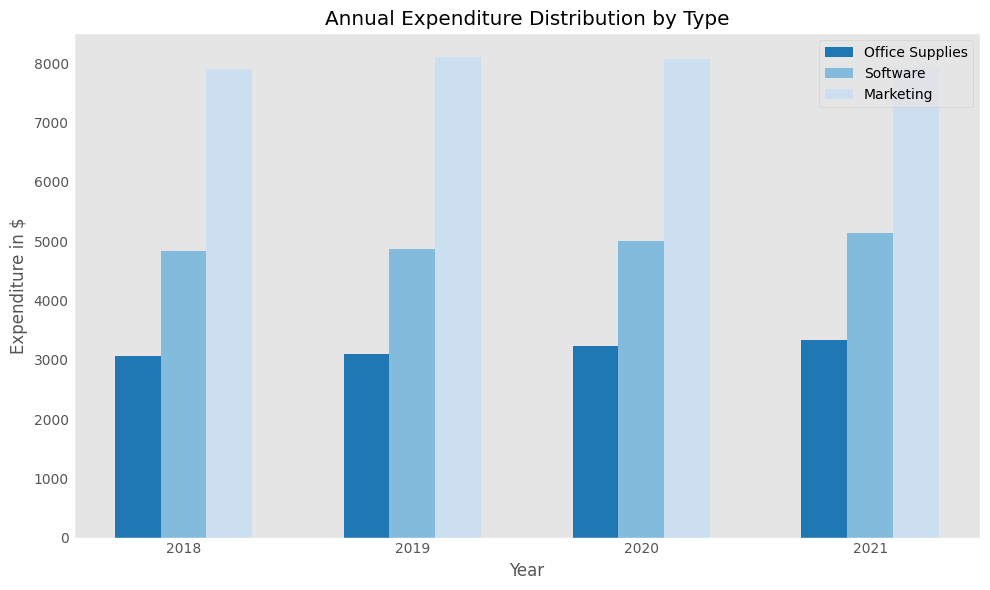What is the average annual expenditure on Marketing in 2020? First, locate the bars related to Marketing for the year 2020. The expenditures are shown as a single bar's height. Calculate the average from the three expenditures observed. Final calculation: (8400 + 7600 + 8200)/3 = 8067
Answer: 8067 Which year had the highest average expenditure on Software? Compare the average heights of the Software bars for each year by visual inspection. The tallest average bar represents the highest expenditure. From a glance, 2021 has the tallest Software bar. Confirm by referring to exact numbers: average for 2021 is 5133.33.
Answer: 2021 How much more was spent on Office Supplies in 2021 compared to 2018? Identify and compare the annual average expenditure bars for Office Supplies in 2021 versus 2018. For 2018: (3000 + 3400 + 2800)/3 = 3067. For 2021: (3300 + 3600 + 3100)/3 = 3333. Difference: 3333 - 3067 = 266
Answer: 266 What is the overall trend in average expenditure on Marketing from 2018 to 2021? Observe the heights of Marketing expenditure bars over the years. Visualize any increasing or decreasing patterns across the plotted years. There is a slight decrease over the years by visual judgement, which can be cross-verified by exact calculation.
Answer: Slightly decreasing Which category had the most consistent expenditure across all years? Check the range of the heights of the expenditure bars for each category over the years. The category with the least variation in height indicates the most consistent spending. By visual inspection, Software appears most consistent.
Answer: Software In which year did the average expenditure on Office Supplies exceed that of Marketing? Compare the average bar heights of Office Supplies and Marketing for each year. In 2021, Office Supplies average bar height exceeds Marketing average bar height. Confirm by exact numbers (Office Supplies: 3333, Marketing: 7933)
Answer: None In 2020, which category saw the highest average expenditure? Look at the heights of the bars for 2020 and find the tallest bar which represents the highest expenditure. Marketing has the tallest bar indicating the highest expenditure.
Answer: Marketing Which had a higher average expenditure in 2019: Office Supplies or Software? Compare the heights of the average expenditure bars of Office Supplies and Software in 2019. Software bar appears taller. Confirm with exact numbers (Office Supplies: 3100 , Software: 4900).
Answer: Software 